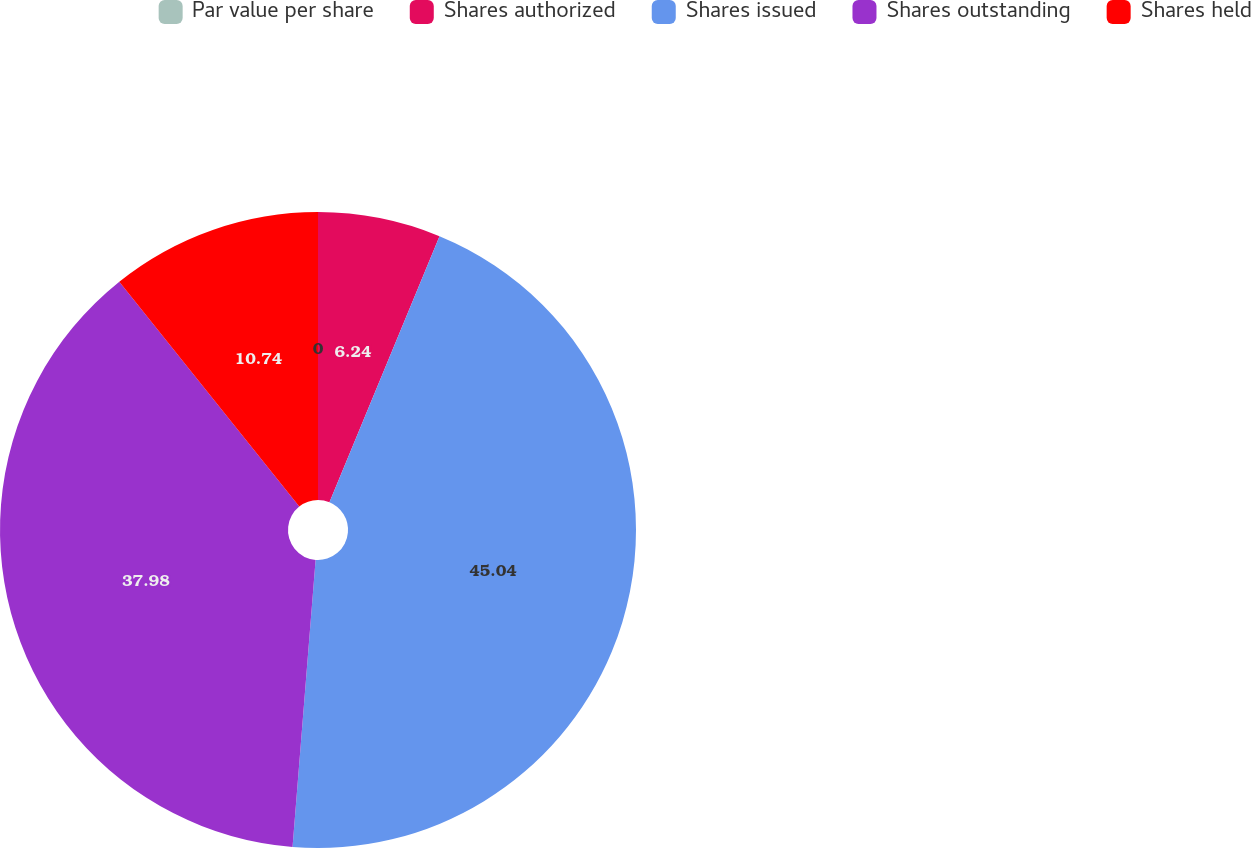Convert chart to OTSL. <chart><loc_0><loc_0><loc_500><loc_500><pie_chart><fcel>Par value per share<fcel>Shares authorized<fcel>Shares issued<fcel>Shares outstanding<fcel>Shares held<nl><fcel>0.0%<fcel>6.24%<fcel>45.03%<fcel>37.98%<fcel>10.74%<nl></chart> 